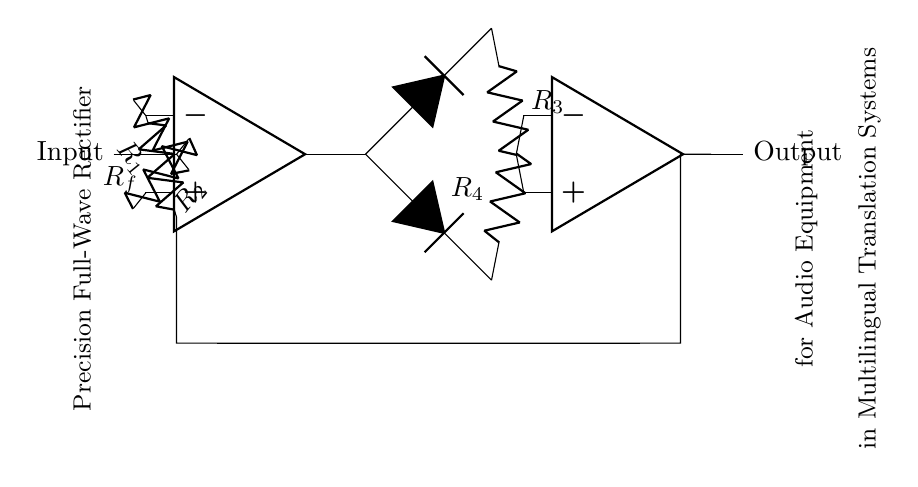What is the first component connected to the input? The first component connected to the input is a resistor labeled R1, which is connected to the inverting input of the first op-amp.
Answer: R1 How many op-amps are used in this circuit? The circuit uses two op-amps, depicted as blocks labeled appropriately in the diagram.
Answer: 2 What is the purpose of the diodes in this circuit? The diodes in the circuit serve to allow current to flow in one direction only, effectively facilitating the rectification process for both halves of the AC input signal through the full-wave rectifier configuration.
Answer: Rectification What is the value of the feedback resistor connected to the first op-amp? The feedback resistor connected to the first op-amp is labeled as Rf, which loops back from the output of the second op-amp to the inverting input of the first op-amp.
Answer: Rf What type of rectifier configuration is this circuit? This circuit implements a precision full-wave rectifier configuration, which is designed to accurately convert the AC input signal into a corresponding DC output without significant loss.
Answer: Full-wave What happens to the output signal when the input voltage is negative? When the input voltage is negative, the diodes ensure that the output remains positive, allowing for the accurate rectification of the signal without inversion, thus maintaining the precision of the output.
Answer: Output remains positive 